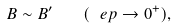Convert formula to latex. <formula><loc_0><loc_0><loc_500><loc_500>B \sim B ^ { \prime } \quad ( \ e p \to 0 ^ { + } ) ,</formula> 